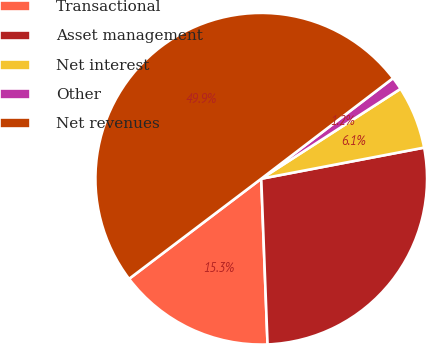<chart> <loc_0><loc_0><loc_500><loc_500><pie_chart><fcel>Transactional<fcel>Asset management<fcel>Net interest<fcel>Other<fcel>Net revenues<nl><fcel>15.29%<fcel>27.4%<fcel>6.12%<fcel>1.25%<fcel>49.95%<nl></chart> 